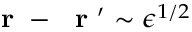<formula> <loc_0><loc_0><loc_500><loc_500>r - r ^ { \prime } \sim \epsilon ^ { 1 / 2 }</formula> 